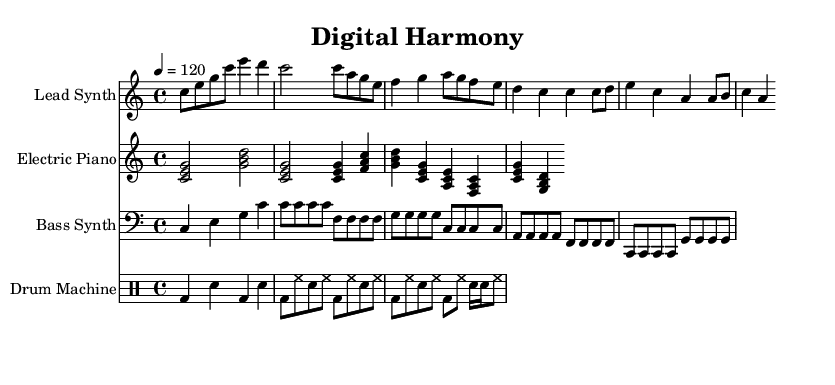What is the key signature of this music? The key signature is C major, which has no sharps or flats.
Answer: C major What is the time signature of this music? The time signature is indicated at the beginning, showing a count of four beats per measure, typically denoted with a fraction.
Answer: 4/4 What is the tempo marking for this piece? The tempo marking indicates how fast the music should be played and is typically noted in beats per minute, starting with the number indicating tempo.
Answer: 120 Which instrument plays the lead melody? The lead melody is often indicated by the highest sounding staff and includes specific notes that define the main theme.
Answer: Lead Synth How many measures are in the verse section? By counting the measures from the beginning of the verse to the end section as shown in the sheet music, we can deduce the total number.
Answer: 8 What type of rhythm is predominantly used in the drum machine part? By reviewing the notation in the drum staff, we can identify the type of percussion rhythm that characterizes the beat and overall feel of the genre.
Answer: Backbeat What fusion style is primarily represented in this music? The unique blending of R&B with electronic elements reflects a contemporary approach to music that incorporates both genres, shown through instrumental variations.
Answer: R&B fusion 